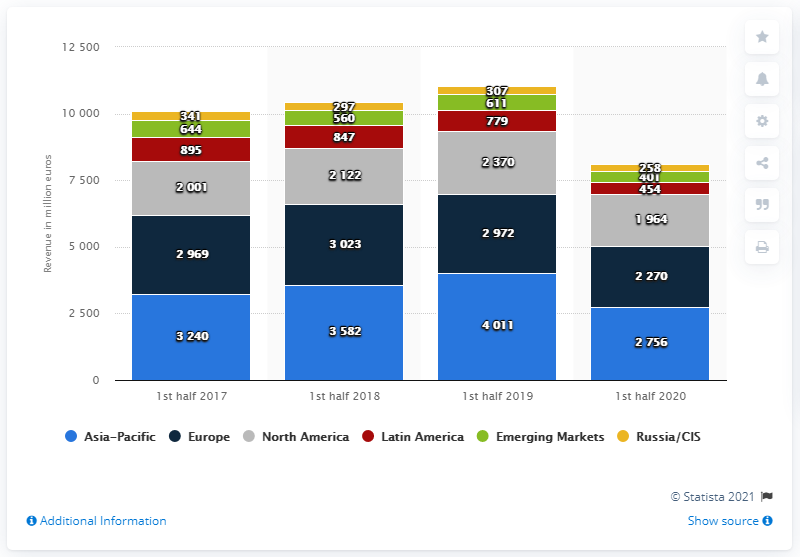Specify some key components in this picture. The revenue generated from the Asia-Pacific region was the highest in the year 2019. In 2020, the total revenue of Adidas from the Europe and North America region was the least among all the years. 